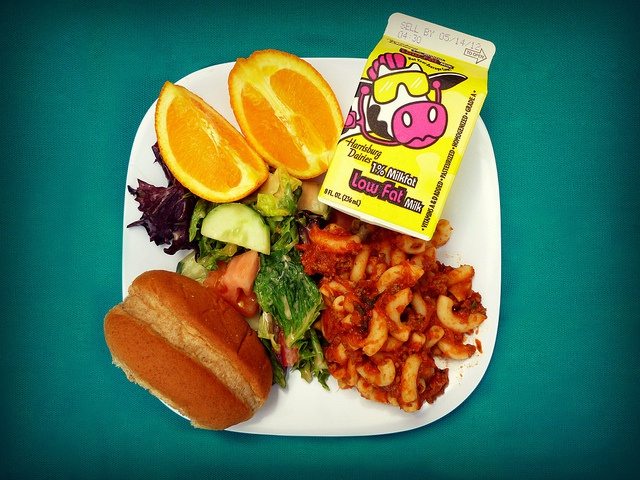Describe the objects in this image and their specific colors. I can see orange in black, orange, gold, and khaki tones and orange in black, orange, khaki, and gold tones in this image. 